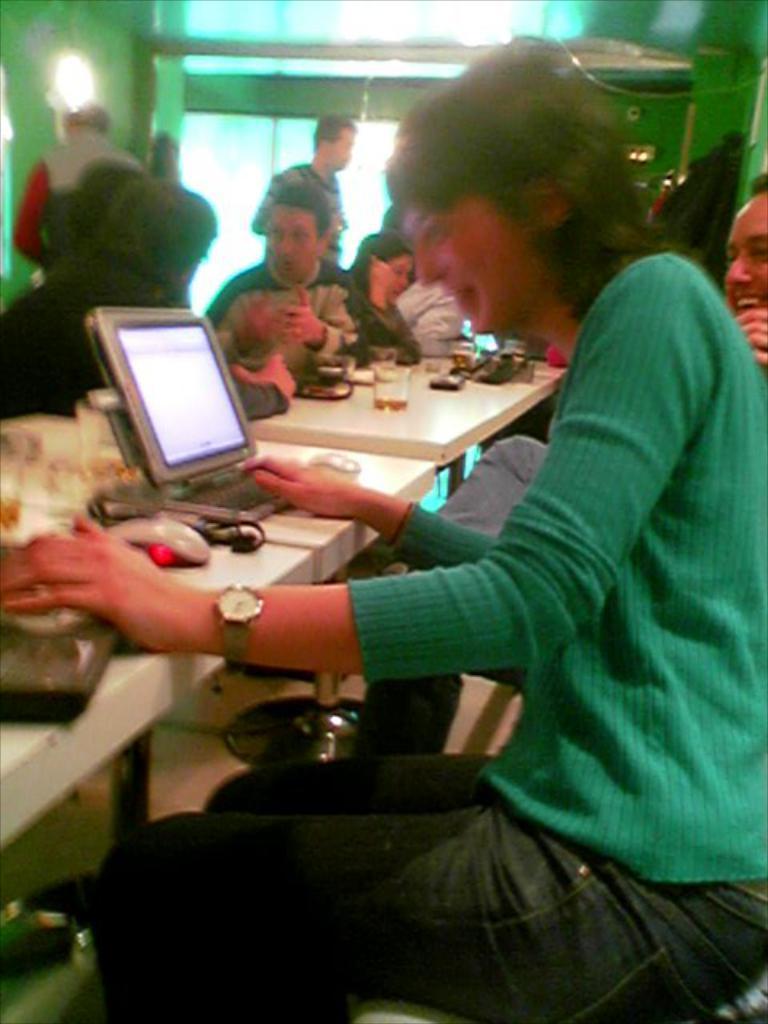Describe this image in one or two sentences. In this image their is a girl who is sitting on the chair and looking at the tab which is in front of her. In the background their are people who are sitting around the table and talking with each other. To the left side top corner there's a light. On the table there are glasses,mouse. 